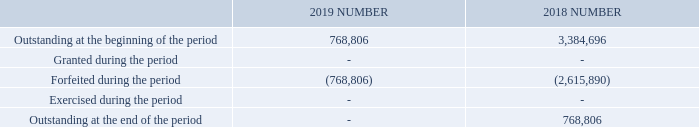5.2 Employee share plans (continued)
FY2019, FY2018 & FY2017 offer under LTI Plan
Each LTI Plan share is offered subject to the achievement of the performance measure, which is tested once at the end of the performance period. The LTI Plans will be measured against one performance measure – relative Total Shareholder Return (TSR). LTI Plan shares that do not vest after testing of the relevant performance measure, lapse without retesting.
The shares will only vest if a certain Total Shareholder Return (TSR) relative to the designated comparator group, being the ASX Small Ordinaries Index excluding mining and energy companies, is achieved during the performance period. In relation to the offer, vesting starts where relative TSR reaches the 50th Percentile.
At the 50th Percentile, 50% of LTI Plan shares will vest. All LTI Plan shares will vest if relative TSR is above the 75th Percentile. Between these points, the percentage of vesting increases on a straight-line basis.
Summary of Shares issued under the FY2017 LTI Plan
The following table illustrates the number of, and movements in, shares issued during the year:
At which percentile will 50% of LTI Plan shares vest? 50th percentile. When will the shares vest? If a certain total shareholder return (tsr) relative to the designated comparator group, being the asx small ordinaries index excluding mining and energy companies, is achieved during the performance period. Which performance measure will the LTI Plans be measured against? Relative total shareholder return (tsr). What is the percentage change in the outstanding number of shares at the beginning of the period from 2018 to 2019?
Answer scale should be: percent. (768,806-3,384,696)/3,384,696
Answer: -77.29. What is the percentage change in the number of forfeited shares during the period from 2018 to 2019?
Answer scale should be: percent. (768,806-2,615,890)/2,615,890
Answer: -70.61. In which year is the number of outstanding shares at the beginning of the period higher? Find the year with the higher number of outstanding shares at the beginning of the period
Answer: 2018. 